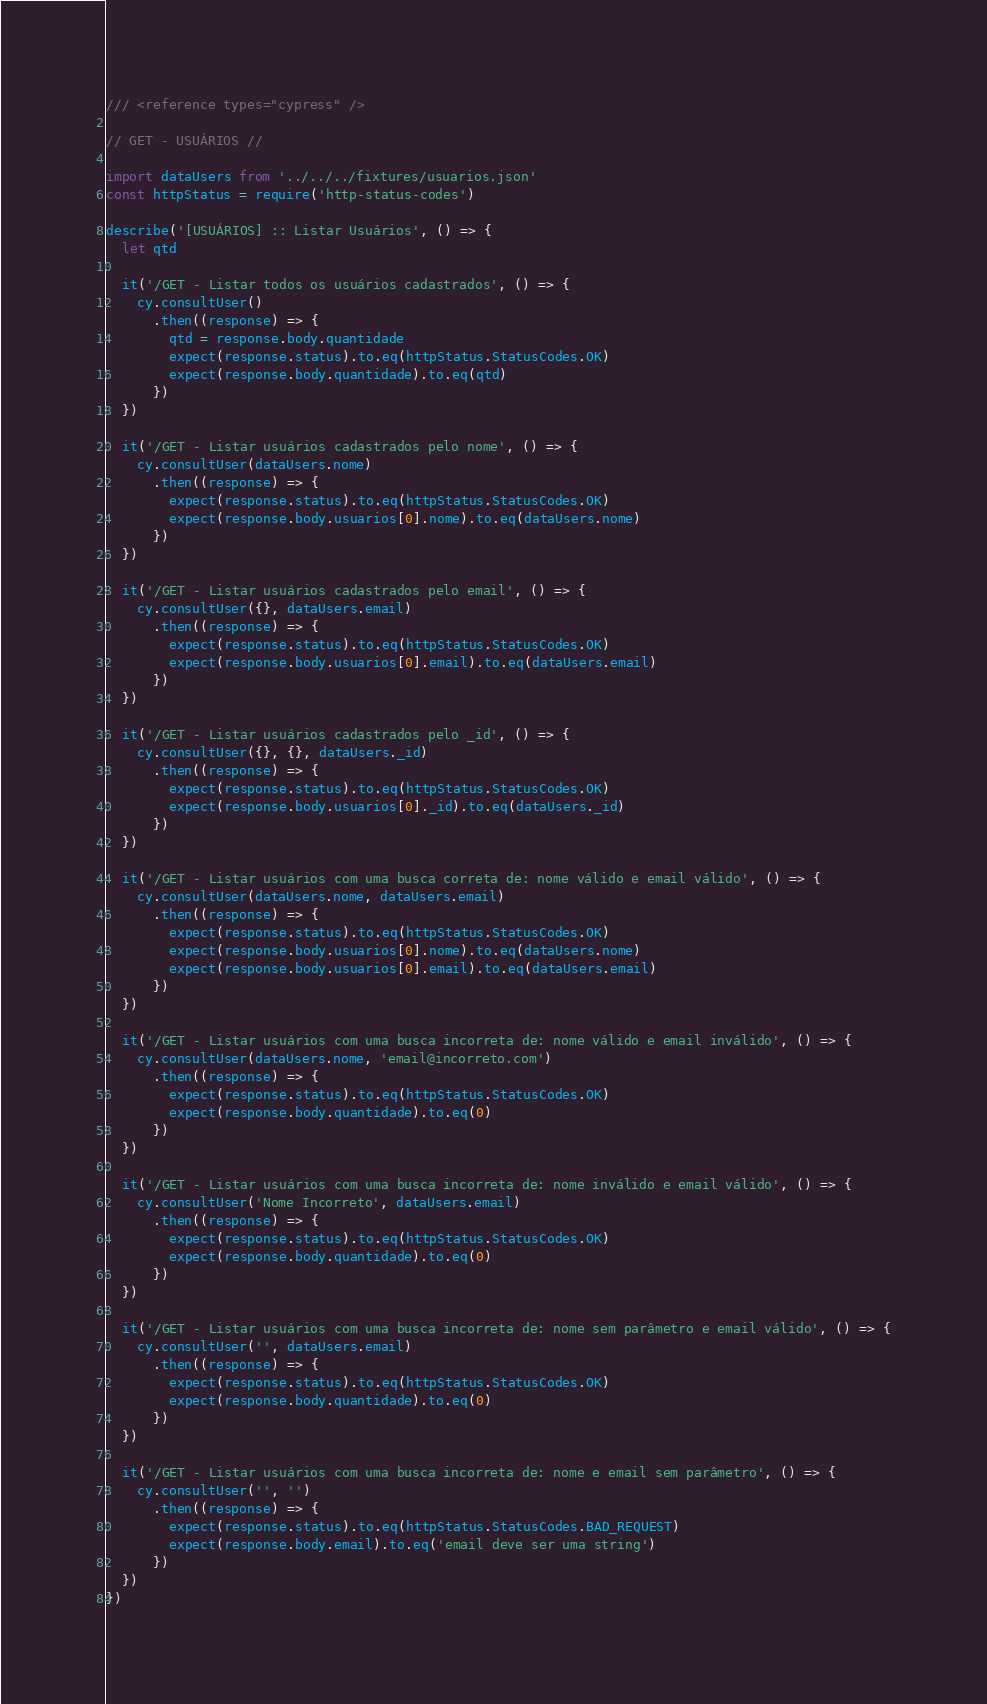<code> <loc_0><loc_0><loc_500><loc_500><_JavaScript_>/// <reference types="cypress" />

// GET - USUÁRIOS //

import dataUsers from '../../../fixtures/usuarios.json'
const httpStatus = require('http-status-codes')

describe('[USUÁRIOS] :: Listar Usuários', () => {
  let qtd

  it('/GET - Listar todos os usuários cadastrados', () => {
    cy.consultUser()
      .then((response) => {
        qtd = response.body.quantidade
        expect(response.status).to.eq(httpStatus.StatusCodes.OK)
        expect(response.body.quantidade).to.eq(qtd)
      })
  })

  it('/GET - Listar usuários cadastrados pelo nome', () => {
    cy.consultUser(dataUsers.nome)
      .then((response) => {
        expect(response.status).to.eq(httpStatus.StatusCodes.OK)
        expect(response.body.usuarios[0].nome).to.eq(dataUsers.nome)
      })
  })

  it('/GET - Listar usuários cadastrados pelo email', () => {
    cy.consultUser({}, dataUsers.email)
      .then((response) => {
        expect(response.status).to.eq(httpStatus.StatusCodes.OK)
        expect(response.body.usuarios[0].email).to.eq(dataUsers.email)
      })
  })

  it('/GET - Listar usuários cadastrados pelo _id', () => {
    cy.consultUser({}, {}, dataUsers._id)
      .then((response) => {
        expect(response.status).to.eq(httpStatus.StatusCodes.OK)
        expect(response.body.usuarios[0]._id).to.eq(dataUsers._id)
      })
  })

  it('/GET - Listar usuários com uma busca correta de: nome válido e email válido', () => {
    cy.consultUser(dataUsers.nome, dataUsers.email)
      .then((response) => {
        expect(response.status).to.eq(httpStatus.StatusCodes.OK)
        expect(response.body.usuarios[0].nome).to.eq(dataUsers.nome)
        expect(response.body.usuarios[0].email).to.eq(dataUsers.email)
      })
  })

  it('/GET - Listar usuários com uma busca incorreta de: nome válido e email inválido', () => {
    cy.consultUser(dataUsers.nome, 'email@incorreto.com')
      .then((response) => {
        expect(response.status).to.eq(httpStatus.StatusCodes.OK)
        expect(response.body.quantidade).to.eq(0)
      })
  })

  it('/GET - Listar usuários com uma busca incorreta de: nome inválido e email válido', () => {
    cy.consultUser('Nome Incorreto', dataUsers.email)
      .then((response) => {
        expect(response.status).to.eq(httpStatus.StatusCodes.OK)
        expect(response.body.quantidade).to.eq(0)
      })
  })

  it('/GET - Listar usuários com uma busca incorreta de: nome sem parâmetro e email válido', () => {
    cy.consultUser('', dataUsers.email)
      .then((response) => {
        expect(response.status).to.eq(httpStatus.StatusCodes.OK)
        expect(response.body.quantidade).to.eq(0)
      })
  })

  it('/GET - Listar usuários com uma busca incorreta de: nome e email sem parâmetro', () => {
    cy.consultUser('', '')
      .then((response) => {
        expect(response.status).to.eq(httpStatus.StatusCodes.BAD_REQUEST)
        expect(response.body.email).to.eq('email deve ser uma string')
      })
  })
})
</code> 